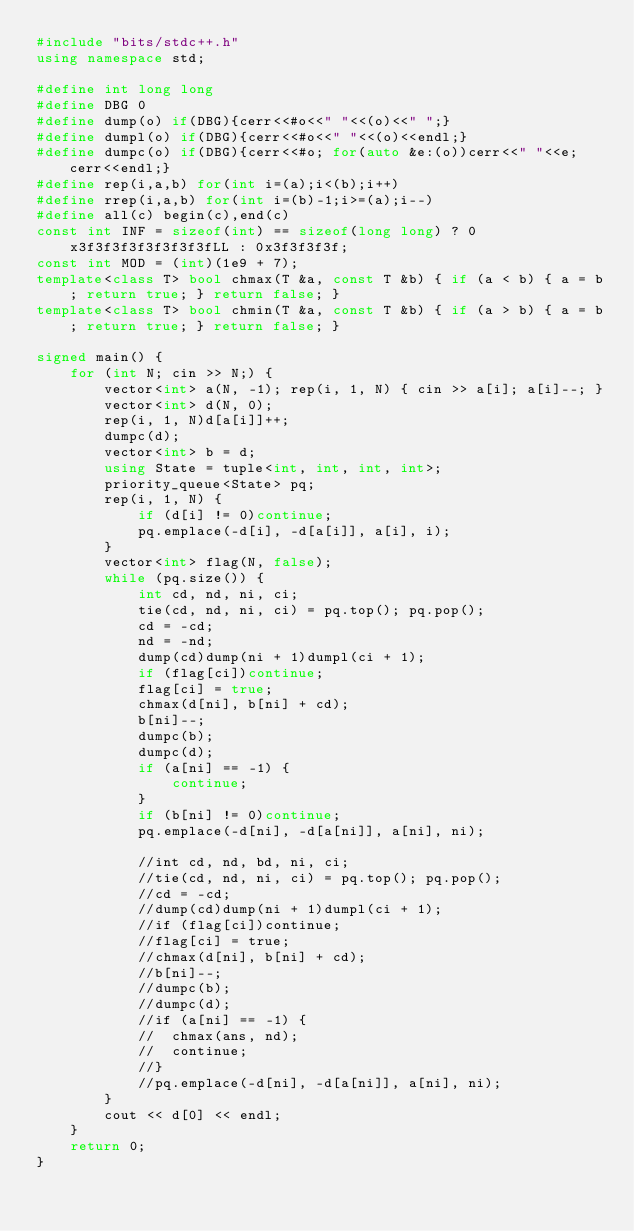<code> <loc_0><loc_0><loc_500><loc_500><_C++_>#include "bits/stdc++.h"
using namespace std;

#define int long long
#define DBG 0
#define dump(o) if(DBG){cerr<<#o<<" "<<(o)<<" ";}
#define dumpl(o) if(DBG){cerr<<#o<<" "<<(o)<<endl;}
#define dumpc(o) if(DBG){cerr<<#o; for(auto &e:(o))cerr<<" "<<e;cerr<<endl;}
#define rep(i,a,b) for(int i=(a);i<(b);i++)
#define rrep(i,a,b) for(int i=(b)-1;i>=(a);i--)
#define all(c) begin(c),end(c)
const int INF = sizeof(int) == sizeof(long long) ? 0x3f3f3f3f3f3f3f3fLL : 0x3f3f3f3f;
const int MOD = (int)(1e9 + 7);
template<class T> bool chmax(T &a, const T &b) { if (a < b) { a = b; return true; } return false; }
template<class T> bool chmin(T &a, const T &b) { if (a > b) { a = b; return true; } return false; }

signed main() {
	for (int N; cin >> N;) {
		vector<int> a(N, -1); rep(i, 1, N) { cin >> a[i]; a[i]--; }
		vector<int> d(N, 0);
		rep(i, 1, N)d[a[i]]++;
		dumpc(d);
		vector<int> b = d;
		using State = tuple<int, int, int, int>;
		priority_queue<State> pq;
		rep(i, 1, N) {
			if (d[i] != 0)continue;
			pq.emplace(-d[i], -d[a[i]], a[i], i);
		}
		vector<int> flag(N, false);
		while (pq.size()) {
			int cd, nd, ni, ci;
			tie(cd, nd, ni, ci) = pq.top(); pq.pop();
			cd = -cd;
			nd = -nd;
			dump(cd)dump(ni + 1)dumpl(ci + 1);
			if (flag[ci])continue;
			flag[ci] = true;
			chmax(d[ni], b[ni] + cd);
			b[ni]--;
			dumpc(b);
			dumpc(d);
			if (a[ni] == -1) {
				continue;
			}
			if (b[ni] != 0)continue;
			pq.emplace(-d[ni], -d[a[ni]], a[ni], ni);

			//int cd, nd, bd, ni, ci;
			//tie(cd, nd, ni, ci) = pq.top(); pq.pop();
			//cd = -cd;
			//dump(cd)dump(ni + 1)dumpl(ci + 1);
			//if (flag[ci])continue;
			//flag[ci] = true;
			//chmax(d[ni], b[ni] + cd);
			//b[ni]--;
			//dumpc(b);
			//dumpc(d);
			//if (a[ni] == -1) {
			//	chmax(ans, nd);
			//	continue;
			//}
			//pq.emplace(-d[ni], -d[a[ni]], a[ni], ni);
		}
		cout << d[0] << endl;
	}
	return 0;
}</code> 